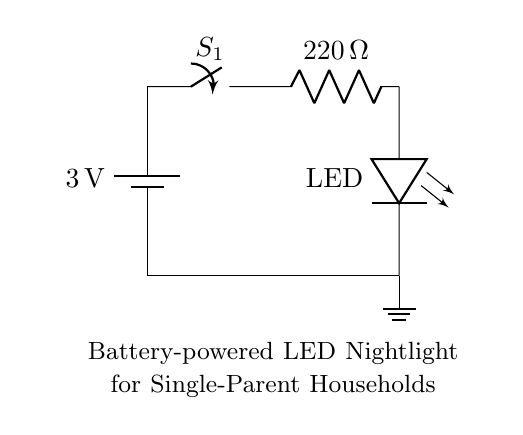What is the voltage of this circuit? The voltage is 3 volts, which is indicated by the battery symbol in the circuit.
Answer: 3 volts What component connects the battery to the rest of the circuit? The component that connects the battery to the circuit is the switch, labeled as S1. It allows for the control of current flow in the circuit.
Answer: Switch How many ohms is the resistor in the circuit? The resistor in the circuit is 220 ohms, as indicated by the label next to the resistor symbol.
Answer: 220 ohms What is the function of the LED in this circuit? The function of the LED is to emit light when current flows through it, providing illumination in the nightlight setup.
Answer: Emit light Why is a 220-ohm resistor used with the LED? A 220-ohm resistor is used to limit the current that flows through the LED, preventing it from receiving excessive current which could damage it. The resistor value is chosen based on the LED's specifications and the battery voltage.
Answer: To limit current What is the total number of components in this circuit? The total number of components includes a battery, a switch, a resistor, and an LED, making it four components altogether.
Answer: Four components 